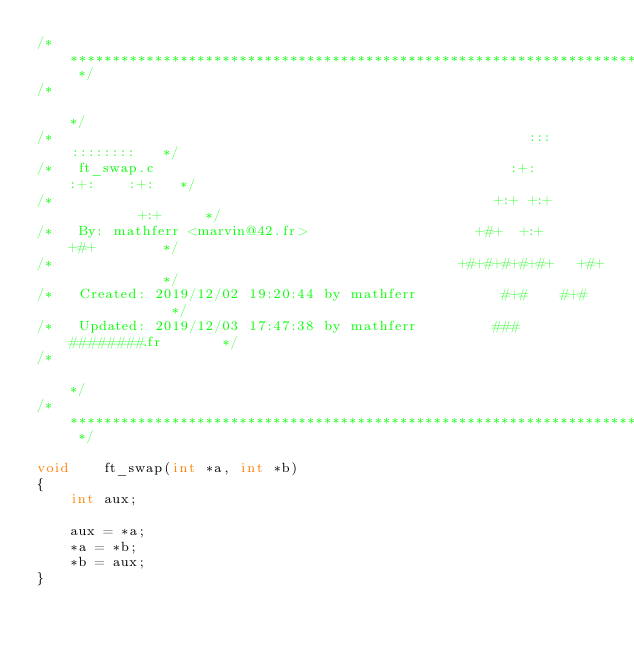Convert code to text. <code><loc_0><loc_0><loc_500><loc_500><_C_>/* ************************************************************************** */
/*                                                                            */
/*                                                        :::      ::::::::   */
/*   ft_swap.c                                          :+:      :+:    :+:   */
/*                                                    +:+ +:+         +:+     */
/*   By: mathferr <marvin@42.fr>                    +#+  +:+       +#+        */
/*                                                +#+#+#+#+#+   +#+           */
/*   Created: 2019/12/02 19:20:44 by mathferr          #+#    #+#             */
/*   Updated: 2019/12/03 17:47:38 by mathferr         ###   ########.fr       */
/*                                                                            */
/* ************************************************************************** */

void	ft_swap(int *a, int *b)
{
	int aux;

	aux = *a;
	*a = *b;
	*b = aux;
}
</code> 